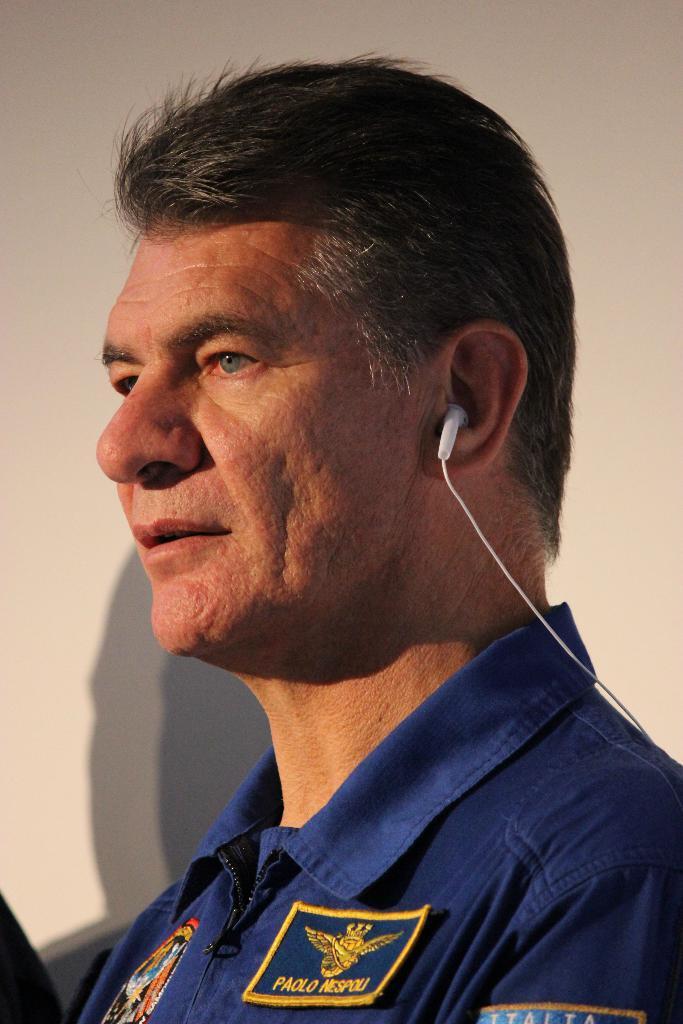In one or two sentences, can you explain what this image depicts? In this image I can see the person with the blue color dress. I can see the cream color background. 